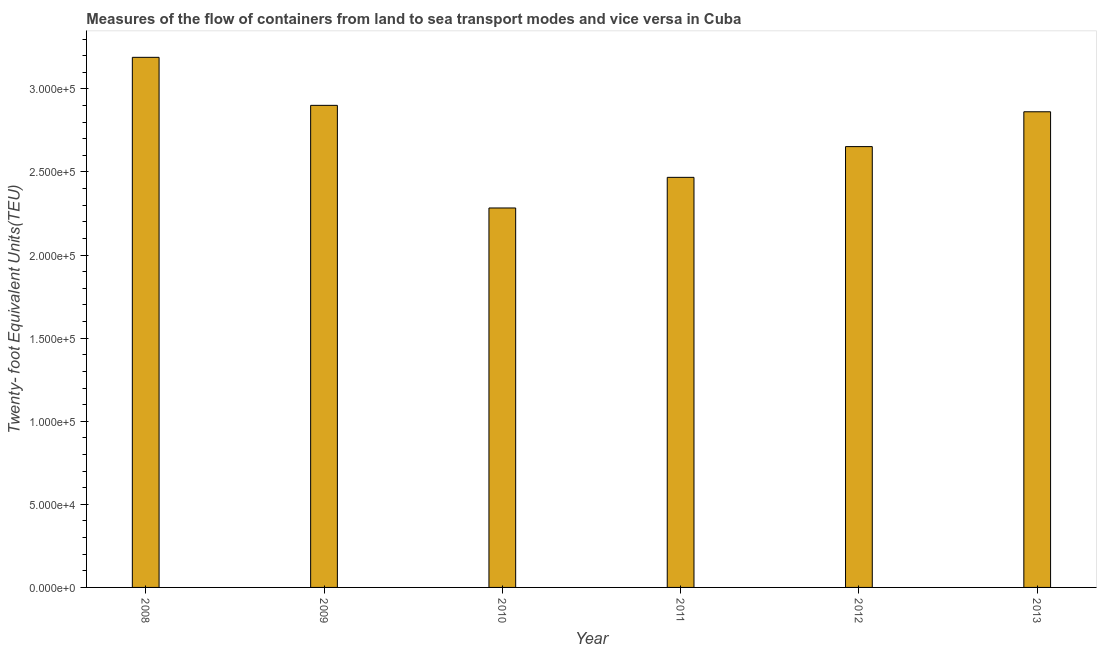Does the graph contain grids?
Keep it short and to the point. No. What is the title of the graph?
Ensure brevity in your answer.  Measures of the flow of containers from land to sea transport modes and vice versa in Cuba. What is the label or title of the X-axis?
Your answer should be compact. Year. What is the label or title of the Y-axis?
Offer a terse response. Twenty- foot Equivalent Units(TEU). What is the container port traffic in 2011?
Ensure brevity in your answer.  2.47e+05. Across all years, what is the maximum container port traffic?
Make the answer very short. 3.19e+05. Across all years, what is the minimum container port traffic?
Offer a very short reply. 2.28e+05. In which year was the container port traffic maximum?
Make the answer very short. 2008. What is the sum of the container port traffic?
Your answer should be compact. 1.64e+06. What is the difference between the container port traffic in 2009 and 2012?
Your response must be concise. 2.48e+04. What is the average container port traffic per year?
Your answer should be very brief. 2.73e+05. What is the median container port traffic?
Your response must be concise. 2.76e+05. What is the ratio of the container port traffic in 2009 to that in 2010?
Your answer should be compact. 1.27. Is the container port traffic in 2011 less than that in 2013?
Keep it short and to the point. Yes. What is the difference between the highest and the second highest container port traffic?
Your answer should be compact. 2.89e+04. What is the difference between the highest and the lowest container port traffic?
Keep it short and to the point. 9.07e+04. How many bars are there?
Your answer should be very brief. 6. Are all the bars in the graph horizontal?
Your answer should be compact. No. What is the Twenty- foot Equivalent Units(TEU) of 2008?
Offer a terse response. 3.19e+05. What is the Twenty- foot Equivalent Units(TEU) in 2009?
Keep it short and to the point. 2.90e+05. What is the Twenty- foot Equivalent Units(TEU) in 2010?
Your answer should be compact. 2.28e+05. What is the Twenty- foot Equivalent Units(TEU) in 2011?
Your answer should be very brief. 2.47e+05. What is the Twenty- foot Equivalent Units(TEU) of 2012?
Provide a short and direct response. 2.65e+05. What is the Twenty- foot Equivalent Units(TEU) of 2013?
Keep it short and to the point. 2.86e+05. What is the difference between the Twenty- foot Equivalent Units(TEU) in 2008 and 2009?
Your response must be concise. 2.89e+04. What is the difference between the Twenty- foot Equivalent Units(TEU) in 2008 and 2010?
Offer a terse response. 9.07e+04. What is the difference between the Twenty- foot Equivalent Units(TEU) in 2008 and 2011?
Provide a succinct answer. 7.22e+04. What is the difference between the Twenty- foot Equivalent Units(TEU) in 2008 and 2012?
Your response must be concise. 5.37e+04. What is the difference between the Twenty- foot Equivalent Units(TEU) in 2008 and 2013?
Provide a short and direct response. 3.28e+04. What is the difference between the Twenty- foot Equivalent Units(TEU) in 2009 and 2010?
Give a very brief answer. 6.18e+04. What is the difference between the Twenty- foot Equivalent Units(TEU) in 2009 and 2011?
Keep it short and to the point. 4.33e+04. What is the difference between the Twenty- foot Equivalent Units(TEU) in 2009 and 2012?
Your answer should be compact. 2.48e+04. What is the difference between the Twenty- foot Equivalent Units(TEU) in 2009 and 2013?
Your answer should be very brief. 3860.43. What is the difference between the Twenty- foot Equivalent Units(TEU) in 2010 and 2011?
Your response must be concise. -1.84e+04. What is the difference between the Twenty- foot Equivalent Units(TEU) in 2010 and 2012?
Your answer should be very brief. -3.69e+04. What is the difference between the Twenty- foot Equivalent Units(TEU) in 2010 and 2013?
Give a very brief answer. -5.79e+04. What is the difference between the Twenty- foot Equivalent Units(TEU) in 2011 and 2012?
Offer a very short reply. -1.85e+04. What is the difference between the Twenty- foot Equivalent Units(TEU) in 2011 and 2013?
Offer a very short reply. -3.95e+04. What is the difference between the Twenty- foot Equivalent Units(TEU) in 2012 and 2013?
Your response must be concise. -2.10e+04. What is the ratio of the Twenty- foot Equivalent Units(TEU) in 2008 to that in 2010?
Your answer should be compact. 1.4. What is the ratio of the Twenty- foot Equivalent Units(TEU) in 2008 to that in 2011?
Keep it short and to the point. 1.29. What is the ratio of the Twenty- foot Equivalent Units(TEU) in 2008 to that in 2012?
Keep it short and to the point. 1.2. What is the ratio of the Twenty- foot Equivalent Units(TEU) in 2008 to that in 2013?
Provide a short and direct response. 1.11. What is the ratio of the Twenty- foot Equivalent Units(TEU) in 2009 to that in 2010?
Make the answer very short. 1.27. What is the ratio of the Twenty- foot Equivalent Units(TEU) in 2009 to that in 2011?
Offer a very short reply. 1.18. What is the ratio of the Twenty- foot Equivalent Units(TEU) in 2009 to that in 2012?
Give a very brief answer. 1.09. What is the ratio of the Twenty- foot Equivalent Units(TEU) in 2010 to that in 2011?
Your answer should be very brief. 0.93. What is the ratio of the Twenty- foot Equivalent Units(TEU) in 2010 to that in 2012?
Keep it short and to the point. 0.86. What is the ratio of the Twenty- foot Equivalent Units(TEU) in 2010 to that in 2013?
Your response must be concise. 0.8. What is the ratio of the Twenty- foot Equivalent Units(TEU) in 2011 to that in 2013?
Your response must be concise. 0.86. What is the ratio of the Twenty- foot Equivalent Units(TEU) in 2012 to that in 2013?
Ensure brevity in your answer.  0.93. 